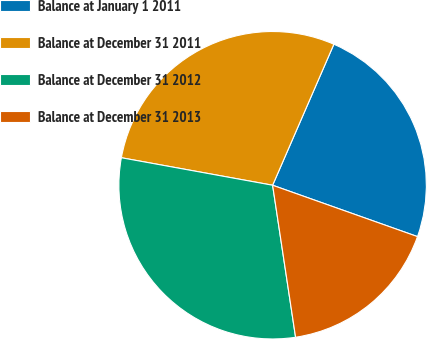<chart> <loc_0><loc_0><loc_500><loc_500><pie_chart><fcel>Balance at January 1 2011<fcel>Balance at December 31 2011<fcel>Balance at December 31 2012<fcel>Balance at December 31 2013<nl><fcel>23.9%<fcel>28.66%<fcel>30.25%<fcel>17.19%<nl></chart> 